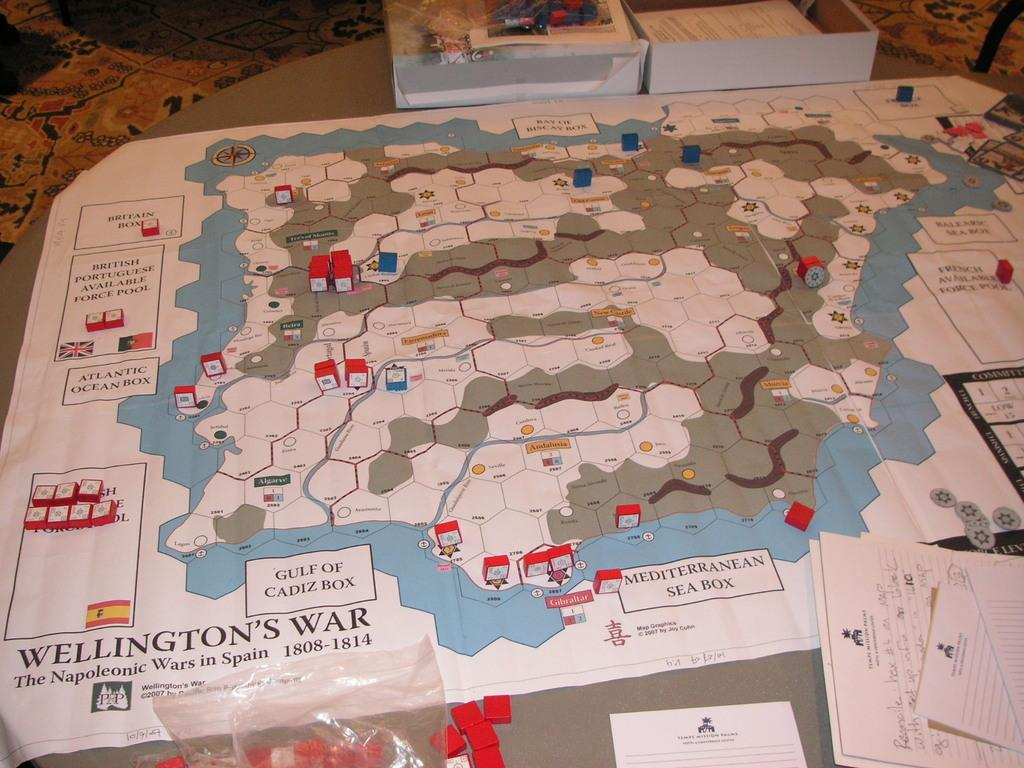<image>
Present a compact description of the photo's key features. A large board game on a table titled Wellington's war 